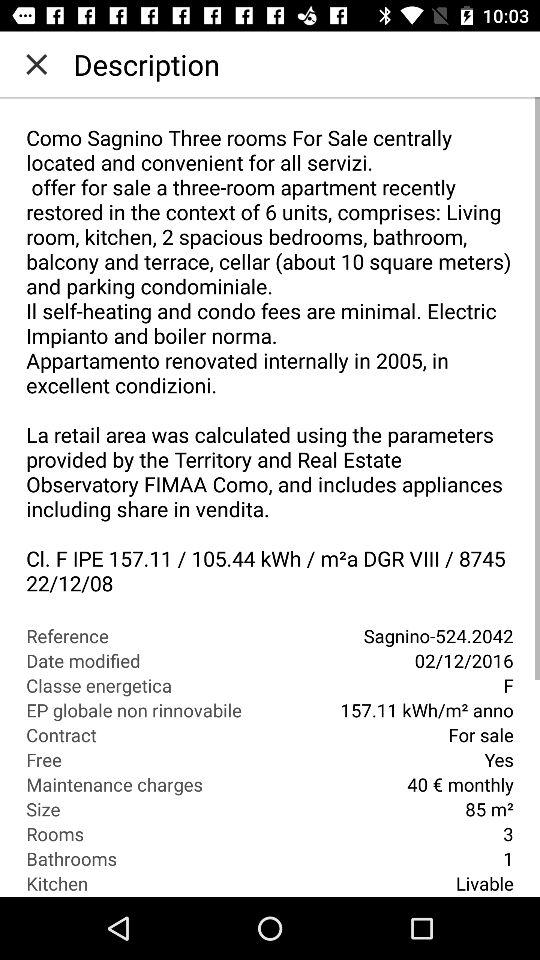How many rooms are there? There are 3 rooms. 